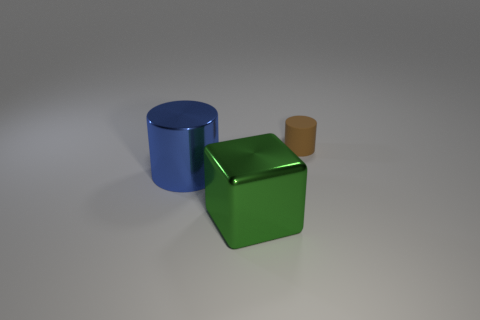There is another big thing that is made of the same material as the big blue object; what is its shape?
Your answer should be compact. Cube. What size is the cylinder that is right of the metal cylinder?
Provide a short and direct response. Small. There is a green shiny thing; what shape is it?
Offer a terse response. Cube. Does the cylinder that is in front of the small brown matte object have the same size as the cylinder that is behind the shiny cylinder?
Your answer should be compact. No. There is a cylinder right of the metal object that is in front of the cylinder in front of the rubber cylinder; how big is it?
Your response must be concise. Small. What shape is the thing that is in front of the cylinder in front of the cylinder that is on the right side of the large green object?
Provide a short and direct response. Cube. What is the shape of the big object in front of the big metal cylinder?
Make the answer very short. Cube. Does the green block have the same material as the cylinder that is on the left side of the large block?
Provide a succinct answer. Yes. What number of other things are the same shape as the tiny brown object?
Provide a succinct answer. 1. Does the matte object have the same color as the cylinder that is in front of the small thing?
Provide a short and direct response. No. 